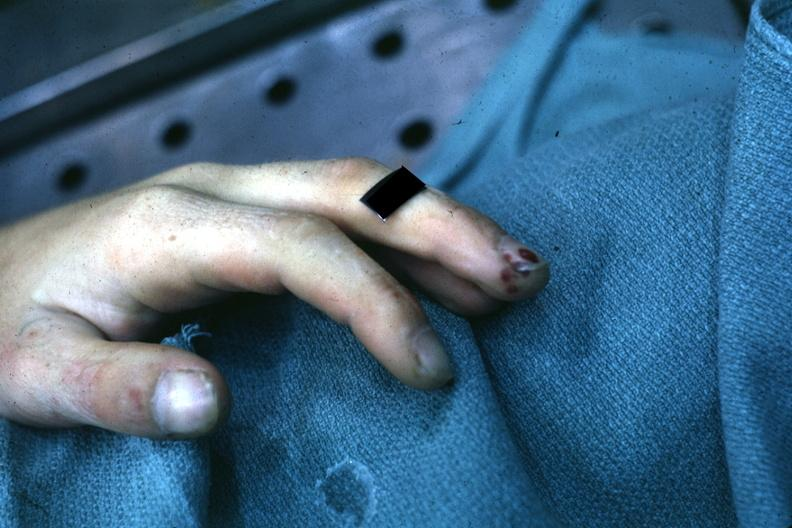what is present?
Answer the question using a single word or phrase. Hand 